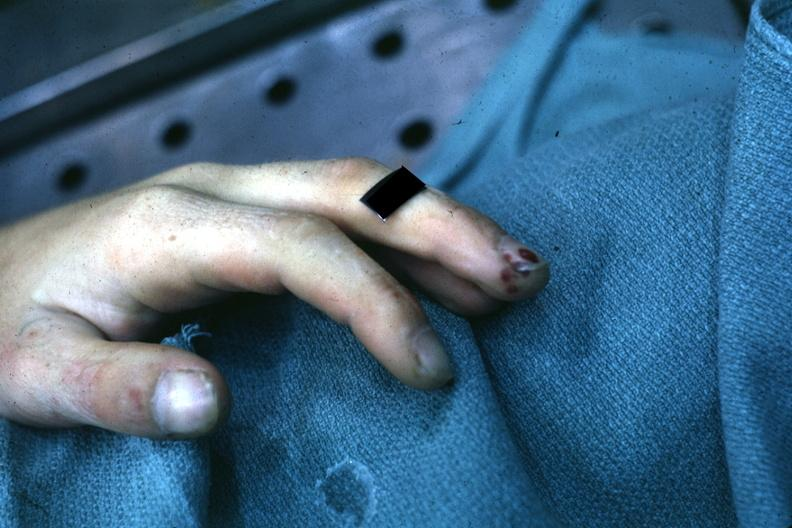what is present?
Answer the question using a single word or phrase. Hand 